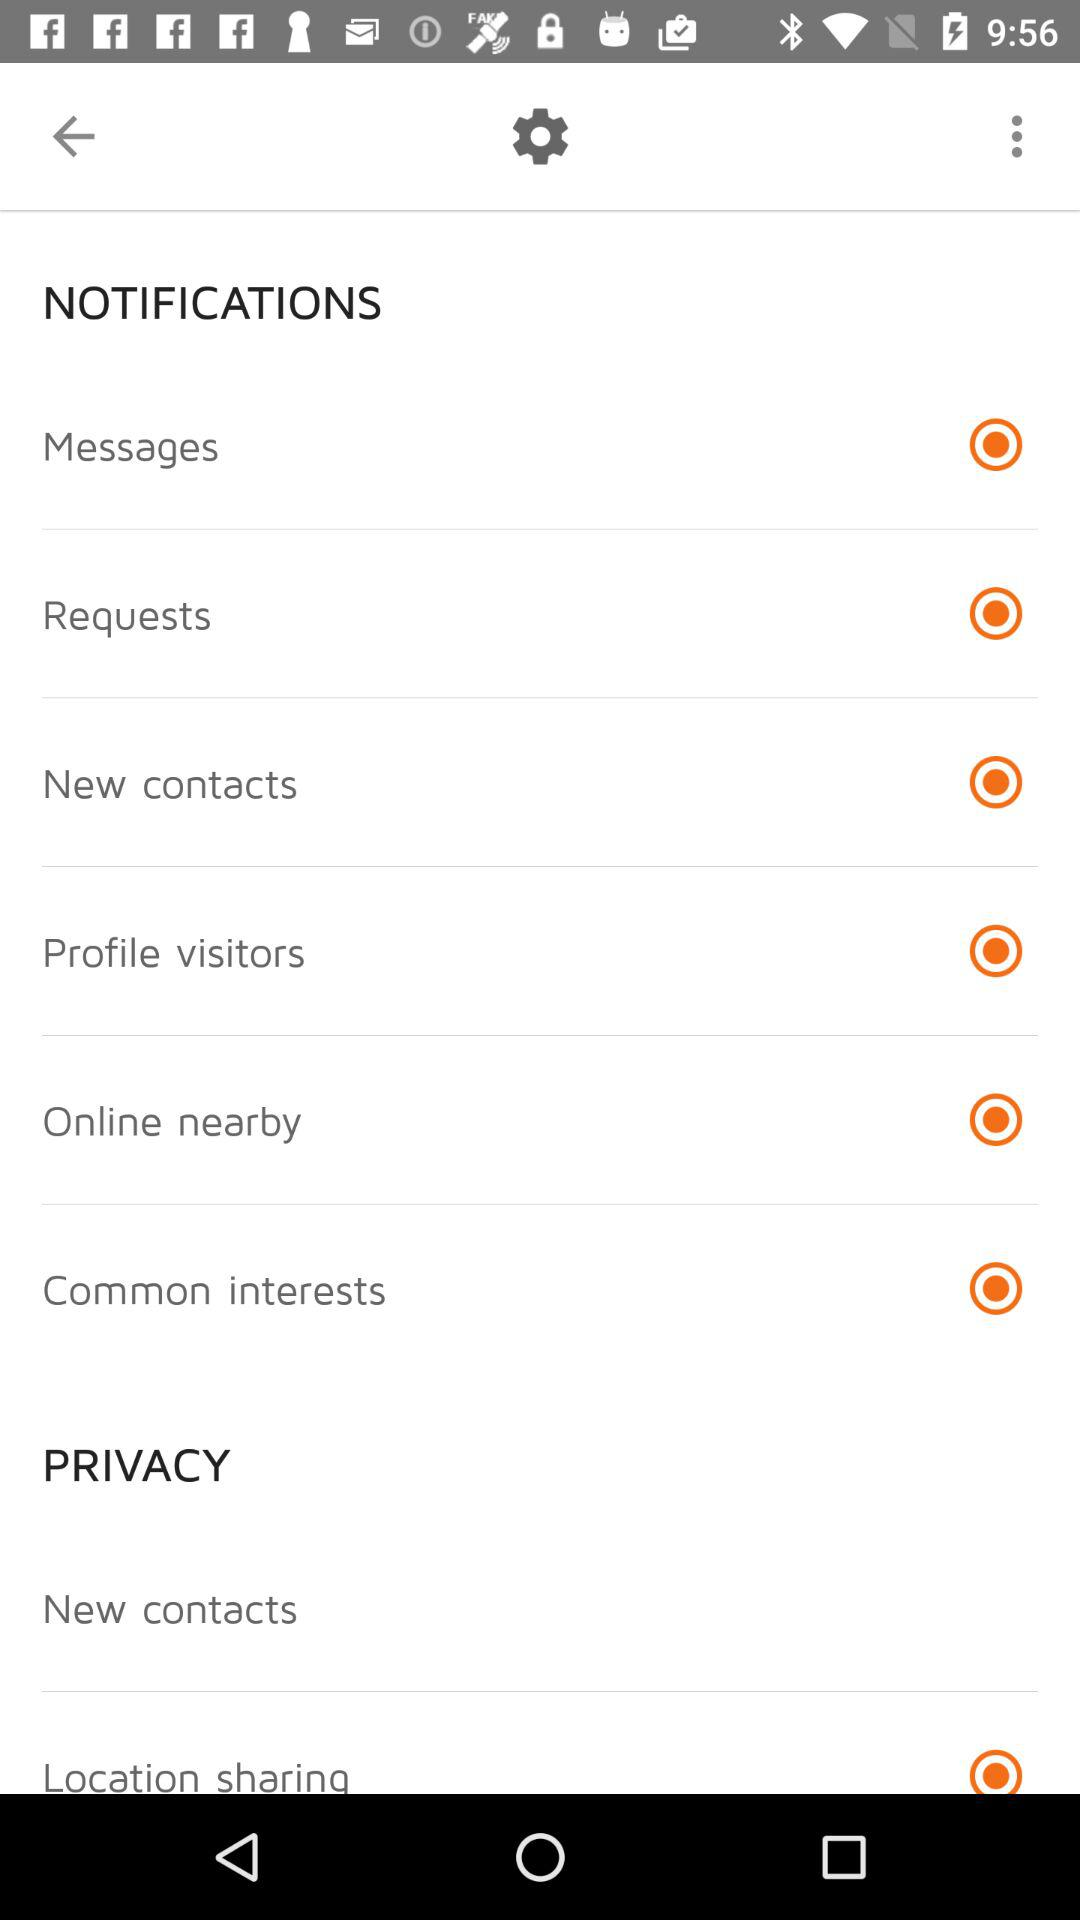What is the status of the notification?
When the provided information is insufficient, respond with <no answer>. <no answer> 